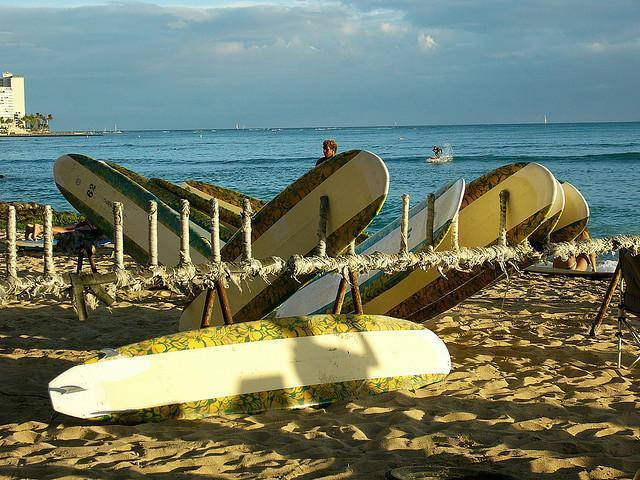How many surfboards are in the picture?
Give a very brief answer. 6. How many boats are there?
Give a very brief answer. 2. How many spoons on the table?
Give a very brief answer. 0. 